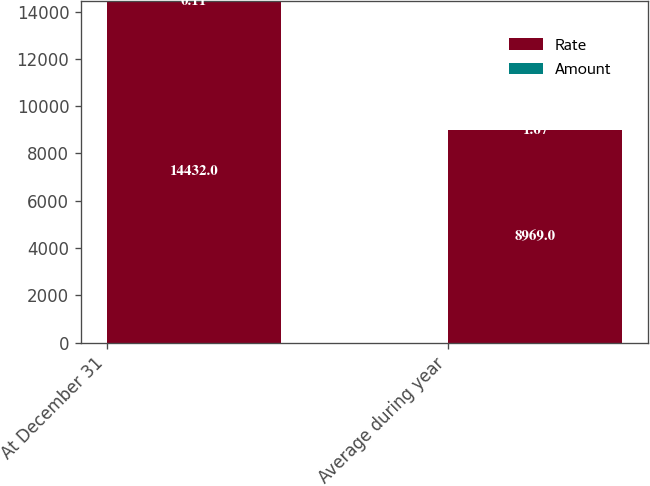<chart> <loc_0><loc_0><loc_500><loc_500><stacked_bar_chart><ecel><fcel>At December 31<fcel>Average during year<nl><fcel>Rate<fcel>14432<fcel>8969<nl><fcel>Amount<fcel>0.11<fcel>1.67<nl></chart> 